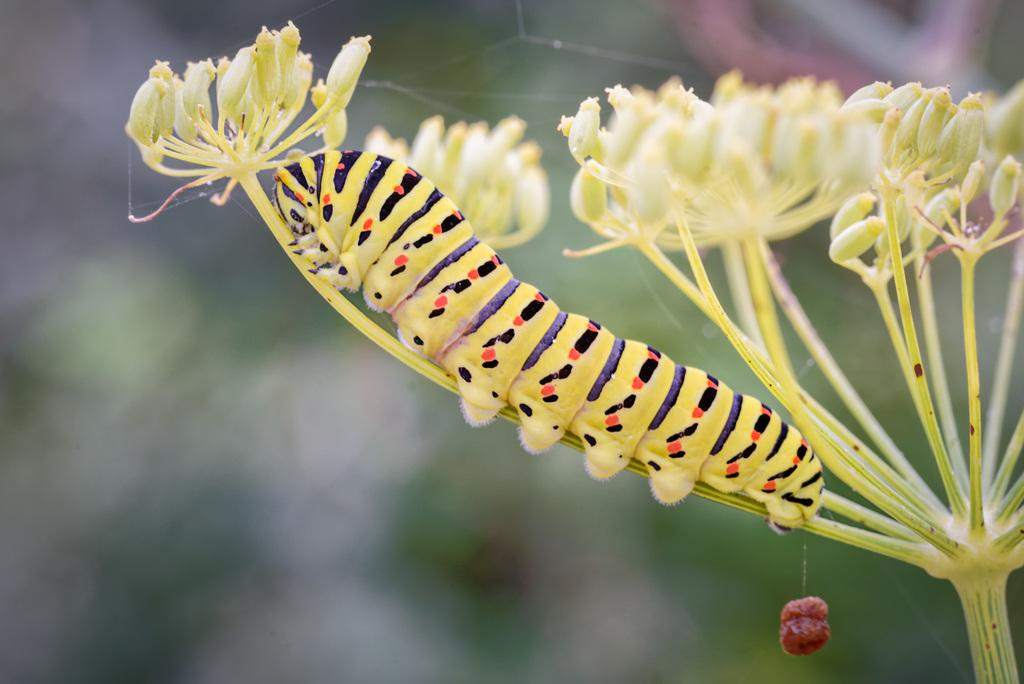What type of living organism can be seen in the image? There is a plant in the image. What is present on the plant? There is an insect on the plant. What else can be seen in the image besides the plant and insect? There is an object in the image. How would you describe the background of the image? The background of the image is blurred. What type of insurance policy is being discussed by the rabbits in the image? There are no rabbits present in the image, and therefore no discussion about insurance policies can be observed. 